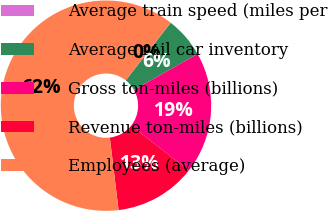<chart> <loc_0><loc_0><loc_500><loc_500><pie_chart><fcel>Average train speed (miles per<fcel>Average rail car inventory<fcel>Gross ton-miles (billions)<fcel>Revenue ton-miles (billions)<fcel>Employees (average)<nl><fcel>0.04%<fcel>6.27%<fcel>18.75%<fcel>12.51%<fcel>62.42%<nl></chart> 